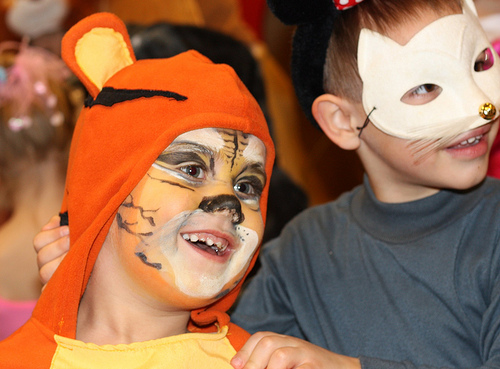<image>
Is there a boy under the boy? No. The boy is not positioned under the boy. The vertical relationship between these objects is different. 